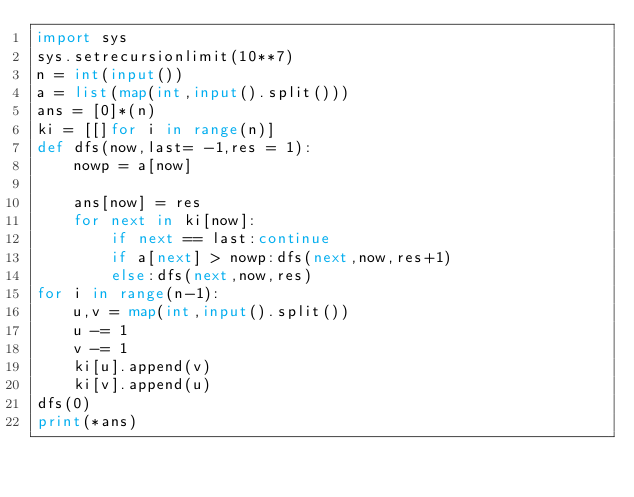<code> <loc_0><loc_0><loc_500><loc_500><_Python_>import sys
sys.setrecursionlimit(10**7)
n = int(input())
a = list(map(int,input().split()))
ans = [0]*(n)
ki = [[]for i in range(n)]
def dfs(now,last= -1,res = 1):
    nowp = a[now]
    
    ans[now] = res
    for next in ki[now]:
        if next == last:continue
        if a[next] > nowp:dfs(next,now,res+1)
        else:dfs(next,now,res)
for i in range(n-1):
    u,v = map(int,input().split())
    u -= 1
    v -= 1
    ki[u].append(v)
    ki[v].append(u)
dfs(0)
print(*ans)</code> 